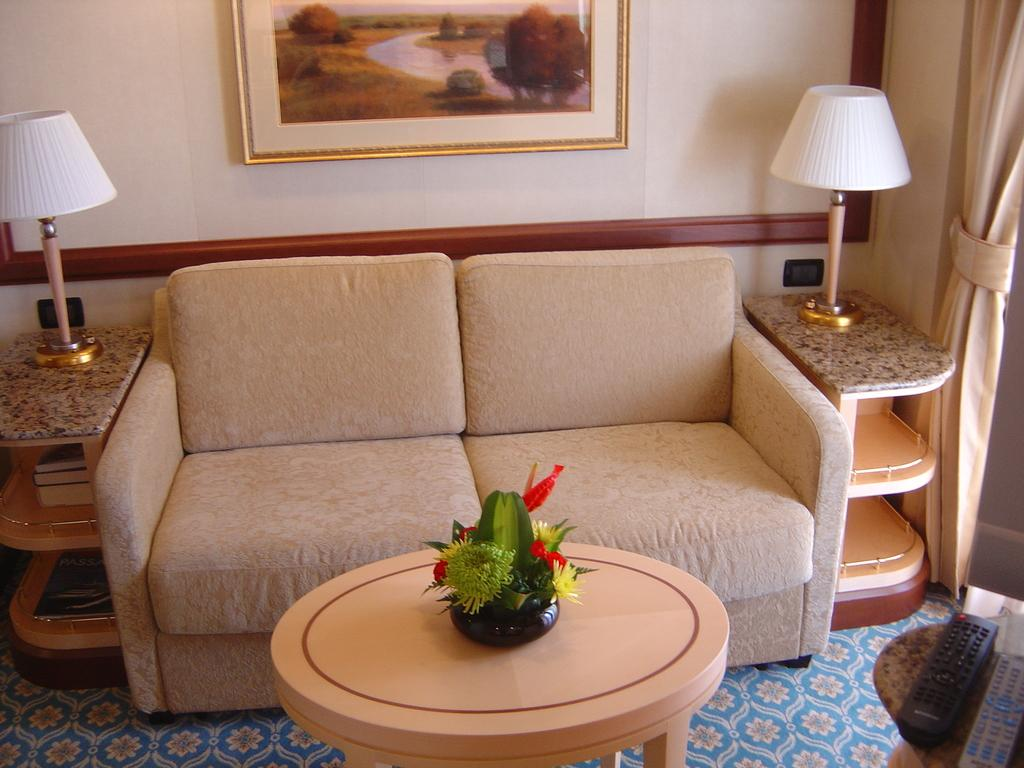What type of furniture is visible in the image? There is an unoccupied sofa in the image. Are there any lighting fixtures near the sofa? Yes, there are two lamps on either side of the sofa. What decorative item can be seen on the wall? There is a painting attached to the wall. What can be found on the center table in the image? There is a flower pot on the center table. How many ladybugs are crawling on the sofa in the image? There are no ladybugs present in the image; the sofa is unoccupied. 